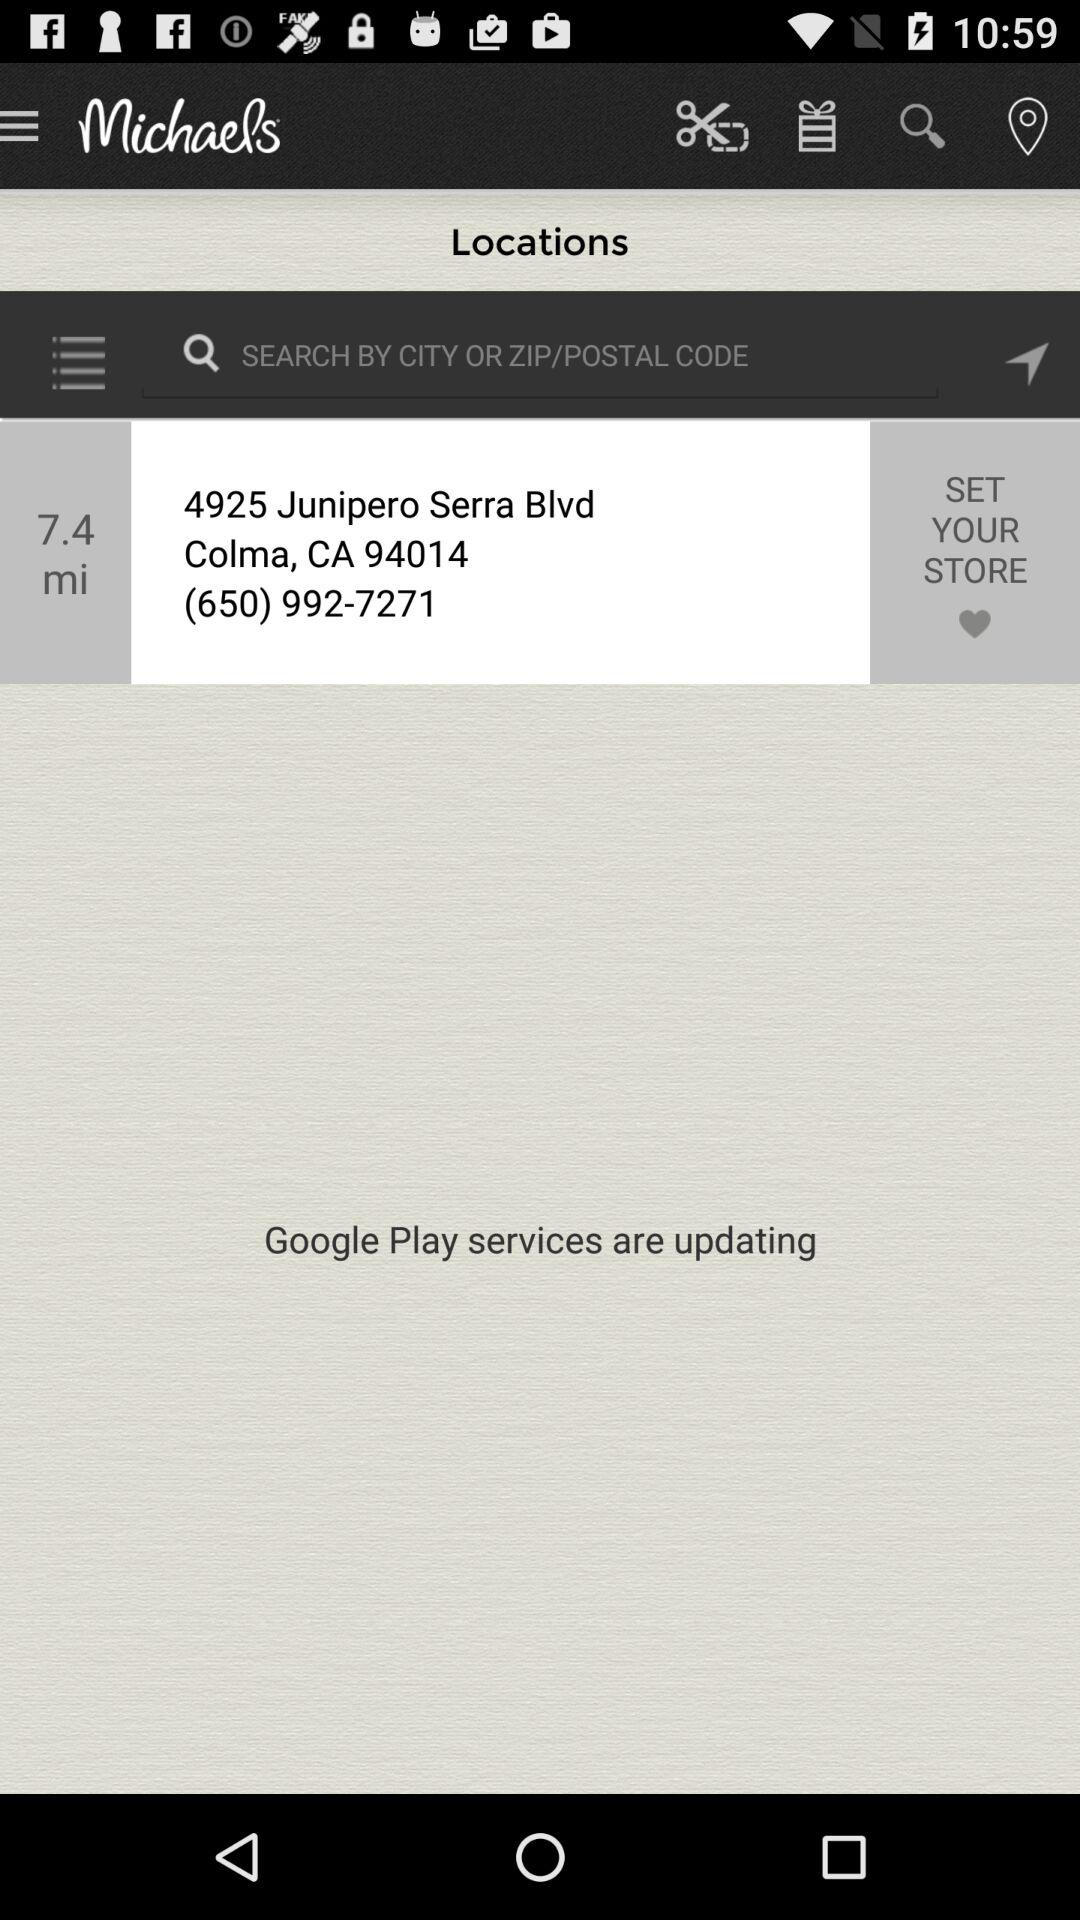What is the given phone number? The given phone number is (650) 992-7271. 